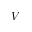<formula> <loc_0><loc_0><loc_500><loc_500>V</formula> 